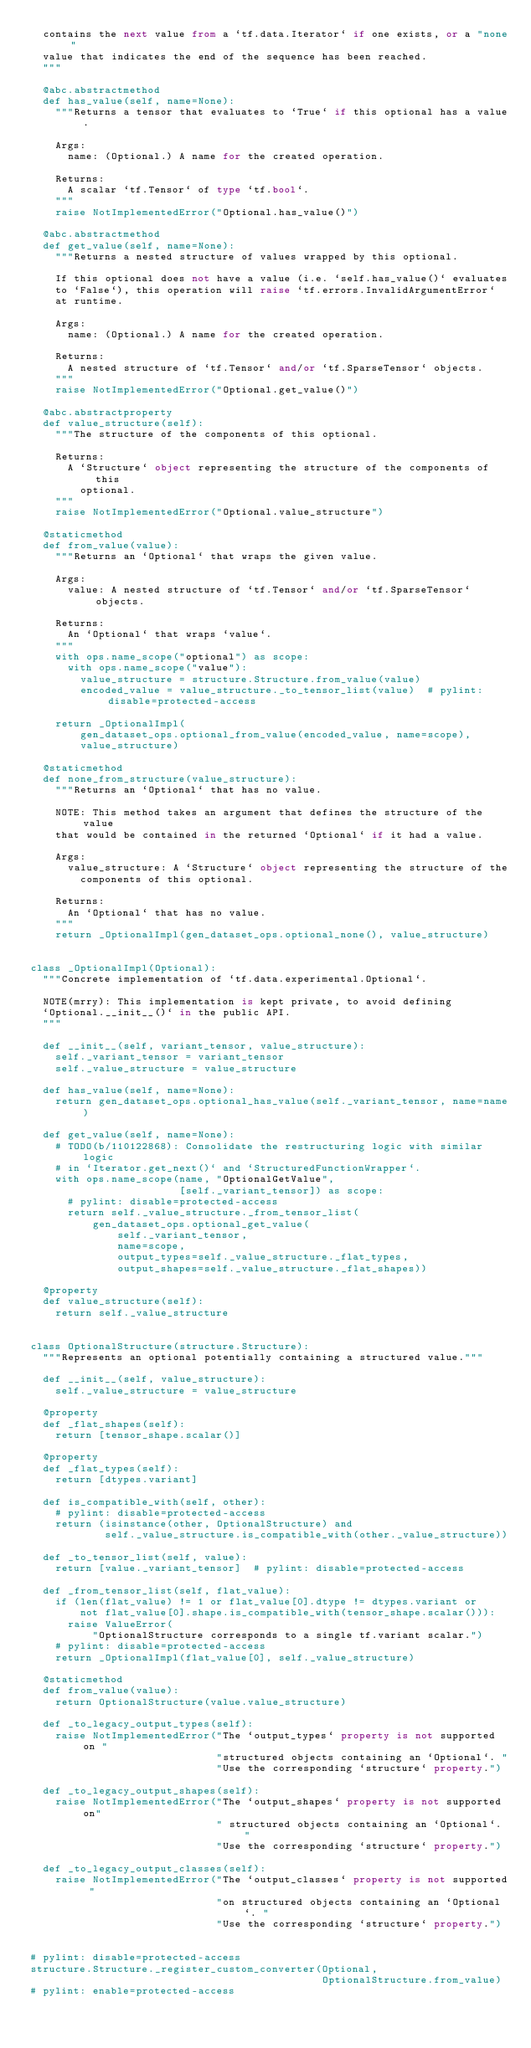Convert code to text. <code><loc_0><loc_0><loc_500><loc_500><_Python_>  contains the next value from a `tf.data.Iterator` if one exists, or a "none"
  value that indicates the end of the sequence has been reached.
  """

  @abc.abstractmethod
  def has_value(self, name=None):
    """Returns a tensor that evaluates to `True` if this optional has a value.

    Args:
      name: (Optional.) A name for the created operation.

    Returns:
      A scalar `tf.Tensor` of type `tf.bool`.
    """
    raise NotImplementedError("Optional.has_value()")

  @abc.abstractmethod
  def get_value(self, name=None):
    """Returns a nested structure of values wrapped by this optional.

    If this optional does not have a value (i.e. `self.has_value()` evaluates
    to `False`), this operation will raise `tf.errors.InvalidArgumentError`
    at runtime.

    Args:
      name: (Optional.) A name for the created operation.

    Returns:
      A nested structure of `tf.Tensor` and/or `tf.SparseTensor` objects.
    """
    raise NotImplementedError("Optional.get_value()")

  @abc.abstractproperty
  def value_structure(self):
    """The structure of the components of this optional.

    Returns:
      A `Structure` object representing the structure of the components of this
        optional.
    """
    raise NotImplementedError("Optional.value_structure")

  @staticmethod
  def from_value(value):
    """Returns an `Optional` that wraps the given value.

    Args:
      value: A nested structure of `tf.Tensor` and/or `tf.SparseTensor` objects.

    Returns:
      An `Optional` that wraps `value`.
    """
    with ops.name_scope("optional") as scope:
      with ops.name_scope("value"):
        value_structure = structure.Structure.from_value(value)
        encoded_value = value_structure._to_tensor_list(value)  # pylint: disable=protected-access

    return _OptionalImpl(
        gen_dataset_ops.optional_from_value(encoded_value, name=scope),
        value_structure)

  @staticmethod
  def none_from_structure(value_structure):
    """Returns an `Optional` that has no value.

    NOTE: This method takes an argument that defines the structure of the value
    that would be contained in the returned `Optional` if it had a value.

    Args:
      value_structure: A `Structure` object representing the structure of the
        components of this optional.

    Returns:
      An `Optional` that has no value.
    """
    return _OptionalImpl(gen_dataset_ops.optional_none(), value_structure)


class _OptionalImpl(Optional):
  """Concrete implementation of `tf.data.experimental.Optional`.

  NOTE(mrry): This implementation is kept private, to avoid defining
  `Optional.__init__()` in the public API.
  """

  def __init__(self, variant_tensor, value_structure):
    self._variant_tensor = variant_tensor
    self._value_structure = value_structure

  def has_value(self, name=None):
    return gen_dataset_ops.optional_has_value(self._variant_tensor, name=name)

  def get_value(self, name=None):
    # TODO(b/110122868): Consolidate the restructuring logic with similar logic
    # in `Iterator.get_next()` and `StructuredFunctionWrapper`.
    with ops.name_scope(name, "OptionalGetValue",
                        [self._variant_tensor]) as scope:
      # pylint: disable=protected-access
      return self._value_structure._from_tensor_list(
          gen_dataset_ops.optional_get_value(
              self._variant_tensor,
              name=scope,
              output_types=self._value_structure._flat_types,
              output_shapes=self._value_structure._flat_shapes))

  @property
  def value_structure(self):
    return self._value_structure


class OptionalStructure(structure.Structure):
  """Represents an optional potentially containing a structured value."""

  def __init__(self, value_structure):
    self._value_structure = value_structure

  @property
  def _flat_shapes(self):
    return [tensor_shape.scalar()]

  @property
  def _flat_types(self):
    return [dtypes.variant]

  def is_compatible_with(self, other):
    # pylint: disable=protected-access
    return (isinstance(other, OptionalStructure) and
            self._value_structure.is_compatible_with(other._value_structure))

  def _to_tensor_list(self, value):
    return [value._variant_tensor]  # pylint: disable=protected-access

  def _from_tensor_list(self, flat_value):
    if (len(flat_value) != 1 or flat_value[0].dtype != dtypes.variant or
        not flat_value[0].shape.is_compatible_with(tensor_shape.scalar())):
      raise ValueError(
          "OptionalStructure corresponds to a single tf.variant scalar.")
    # pylint: disable=protected-access
    return _OptionalImpl(flat_value[0], self._value_structure)

  @staticmethod
  def from_value(value):
    return OptionalStructure(value.value_structure)

  def _to_legacy_output_types(self):
    raise NotImplementedError("The `output_types` property is not supported on "
                              "structured objects containing an `Optional`. "
                              "Use the corresponding `structure` property.")

  def _to_legacy_output_shapes(self):
    raise NotImplementedError("The `output_shapes` property is not supported on"
                              " structured objects containing an `Optional`. "
                              "Use the corresponding `structure` property.")

  def _to_legacy_output_classes(self):
    raise NotImplementedError("The `output_classes` property is not supported "
                              "on structured objects containing an `Optional`. "
                              "Use the corresponding `structure` property.")


# pylint: disable=protected-access
structure.Structure._register_custom_converter(Optional,
                                               OptionalStructure.from_value)
# pylint: enable=protected-access
</code> 